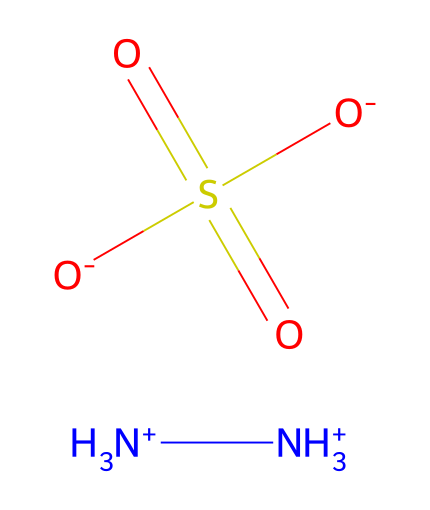What is the chemical name of this compound? The SMILES representation indicates that the compound is composed of nitrogen and sulfate groups. From this, we can identify the chemical as hydrazine sulfate.
Answer: hydrazine sulfate How many nitrogen atoms are present in this chemical? By examining the structure represented in the SMILES, there are two [NH3+] groups, which each contain one nitrogen atom. Therefore, there are a total of two nitrogen atoms.
Answer: 2 What type of functional group is present in this compound? The presence of the sulfate group (S(=O)(=O)[O-]) clearly indicates that the functional group is a sulfate. This is a distinct type of group due to its sulfuric nature.
Answer: sulfate How many oxygen atoms are in hydrazine sulfate? The sulfate group has a total of four oxygen atoms because of its two double bonds to sulfur and two single bonds to oxygen. So, when counted, we find a total of four oxygen atoms in the compound.
Answer: 4 What overall charge does hydrazine sulfate have? The two [NH3+] groups contribute a +2 charge, while the sulfate group [O-] contributes a -2 charge. Adding these gives a total charge of 0, indicating that the compound is neutral.
Answer: 0 Is hydrazine sulfate soluble in water? Hydrazine sulfate is known for its solubility in water due to its ionic nature from the presence of ammonium and sulfate ions, allowing it to interact favorably with water molecules.
Answer: yes 